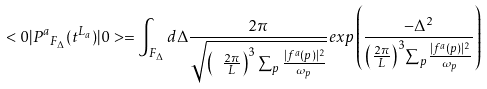<formula> <loc_0><loc_0><loc_500><loc_500>< 0 | { P ^ { a } } _ { F _ { \Delta } } ( t ^ { L _ { a } } ) | 0 > = \int _ { F _ { \Delta } } d \Delta \frac { 2 \pi } { \sqrt { { \left ( \ \frac { 2 \pi } { L } \right ) ^ { 3 } } \sum _ { p } { \frac { | f ^ { a } ( p ) | ^ { 2 } } { \omega _ { p } } } } } e x p \left ( \frac { - { \Delta } ^ { 2 } } { { \left ( \frac { 2 \pi } { L } \right ) ^ { 3 } } { \sum } _ { p } { \frac { | f ^ { a } ( p ) | ^ { 2 } } { \omega _ { p } } } } \right )</formula> 